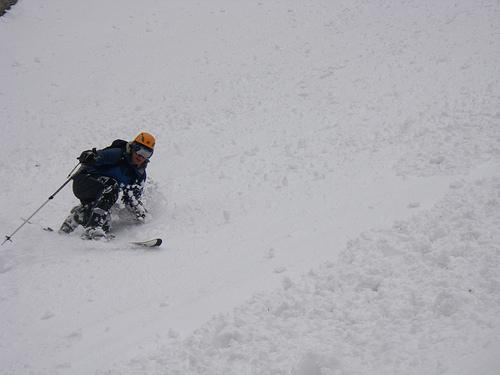Identify and comment on the image's setting. The image takes place on a snowy mountainside during the day, which is a perfect place for skiing. List three objects that the skier is wearing or holding. Yellow helmet, blue jacket, and black ski pole. Estimate the number of different objects detected in the image. Approximately 30 objects have been detected in the image. Name the predominant colors seen in the objects and accessories worn by the skier. Yellow, blue, black, and white. How would you describe the skier's outfit? The skier is wearing a yellow helmet, snow goggles, a blue jacket, black pants, and a snowsuit. Describe the type of weather or environment present in the image. It appears to be a cold, snowy day on a mountain, creating ideal skiing conditions. What are the overall emotions or feelings conveyed by the image? The image conveys excitement, adventure, and the enjoyment of winter sports. What is the main activity happening in the image? A person is skiing down a snow-covered mountainside. 